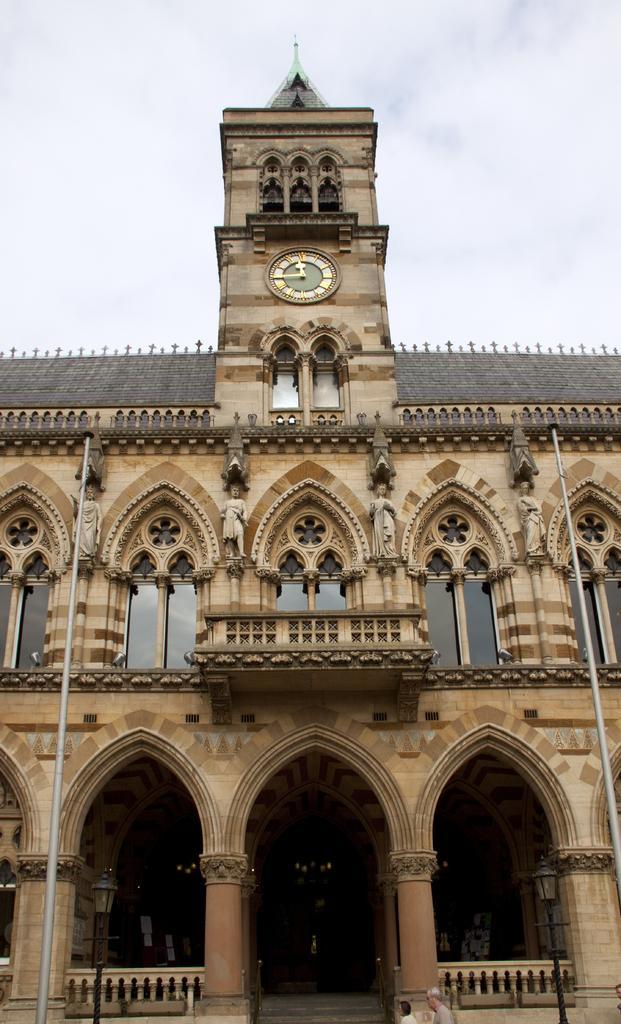Describe this image in one or two sentences. In this image I can see a building, few poles, few windows, few sculptures, a clock and here I can see few people. I can also see few lights and in the background I can see the sky. 